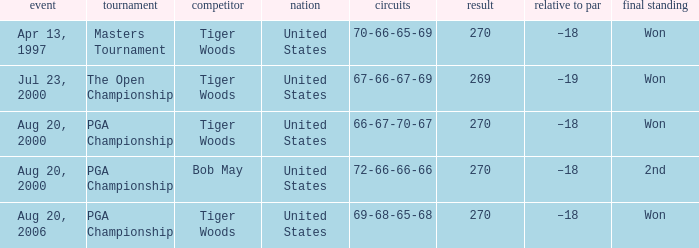What is the worst (highest) score? 270.0. 